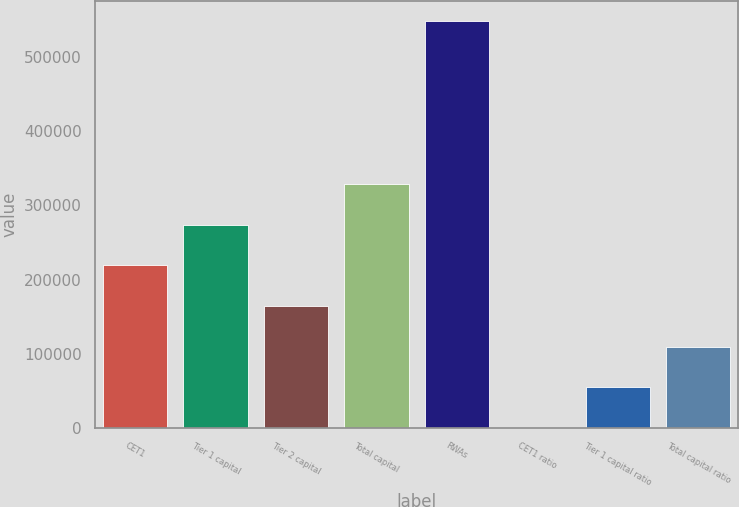Convert chart to OTSL. <chart><loc_0><loc_0><loc_500><loc_500><bar_chart><fcel>CET1<fcel>Tier 1 capital<fcel>Tier 2 capital<fcel>Total capital<fcel>RWAs<fcel>CET1 ratio<fcel>Tier 1 capital ratio<fcel>Total capital ratio<nl><fcel>219172<fcel>273962<fcel>164382<fcel>328751<fcel>547910<fcel>13.3<fcel>54803<fcel>109593<nl></chart> 